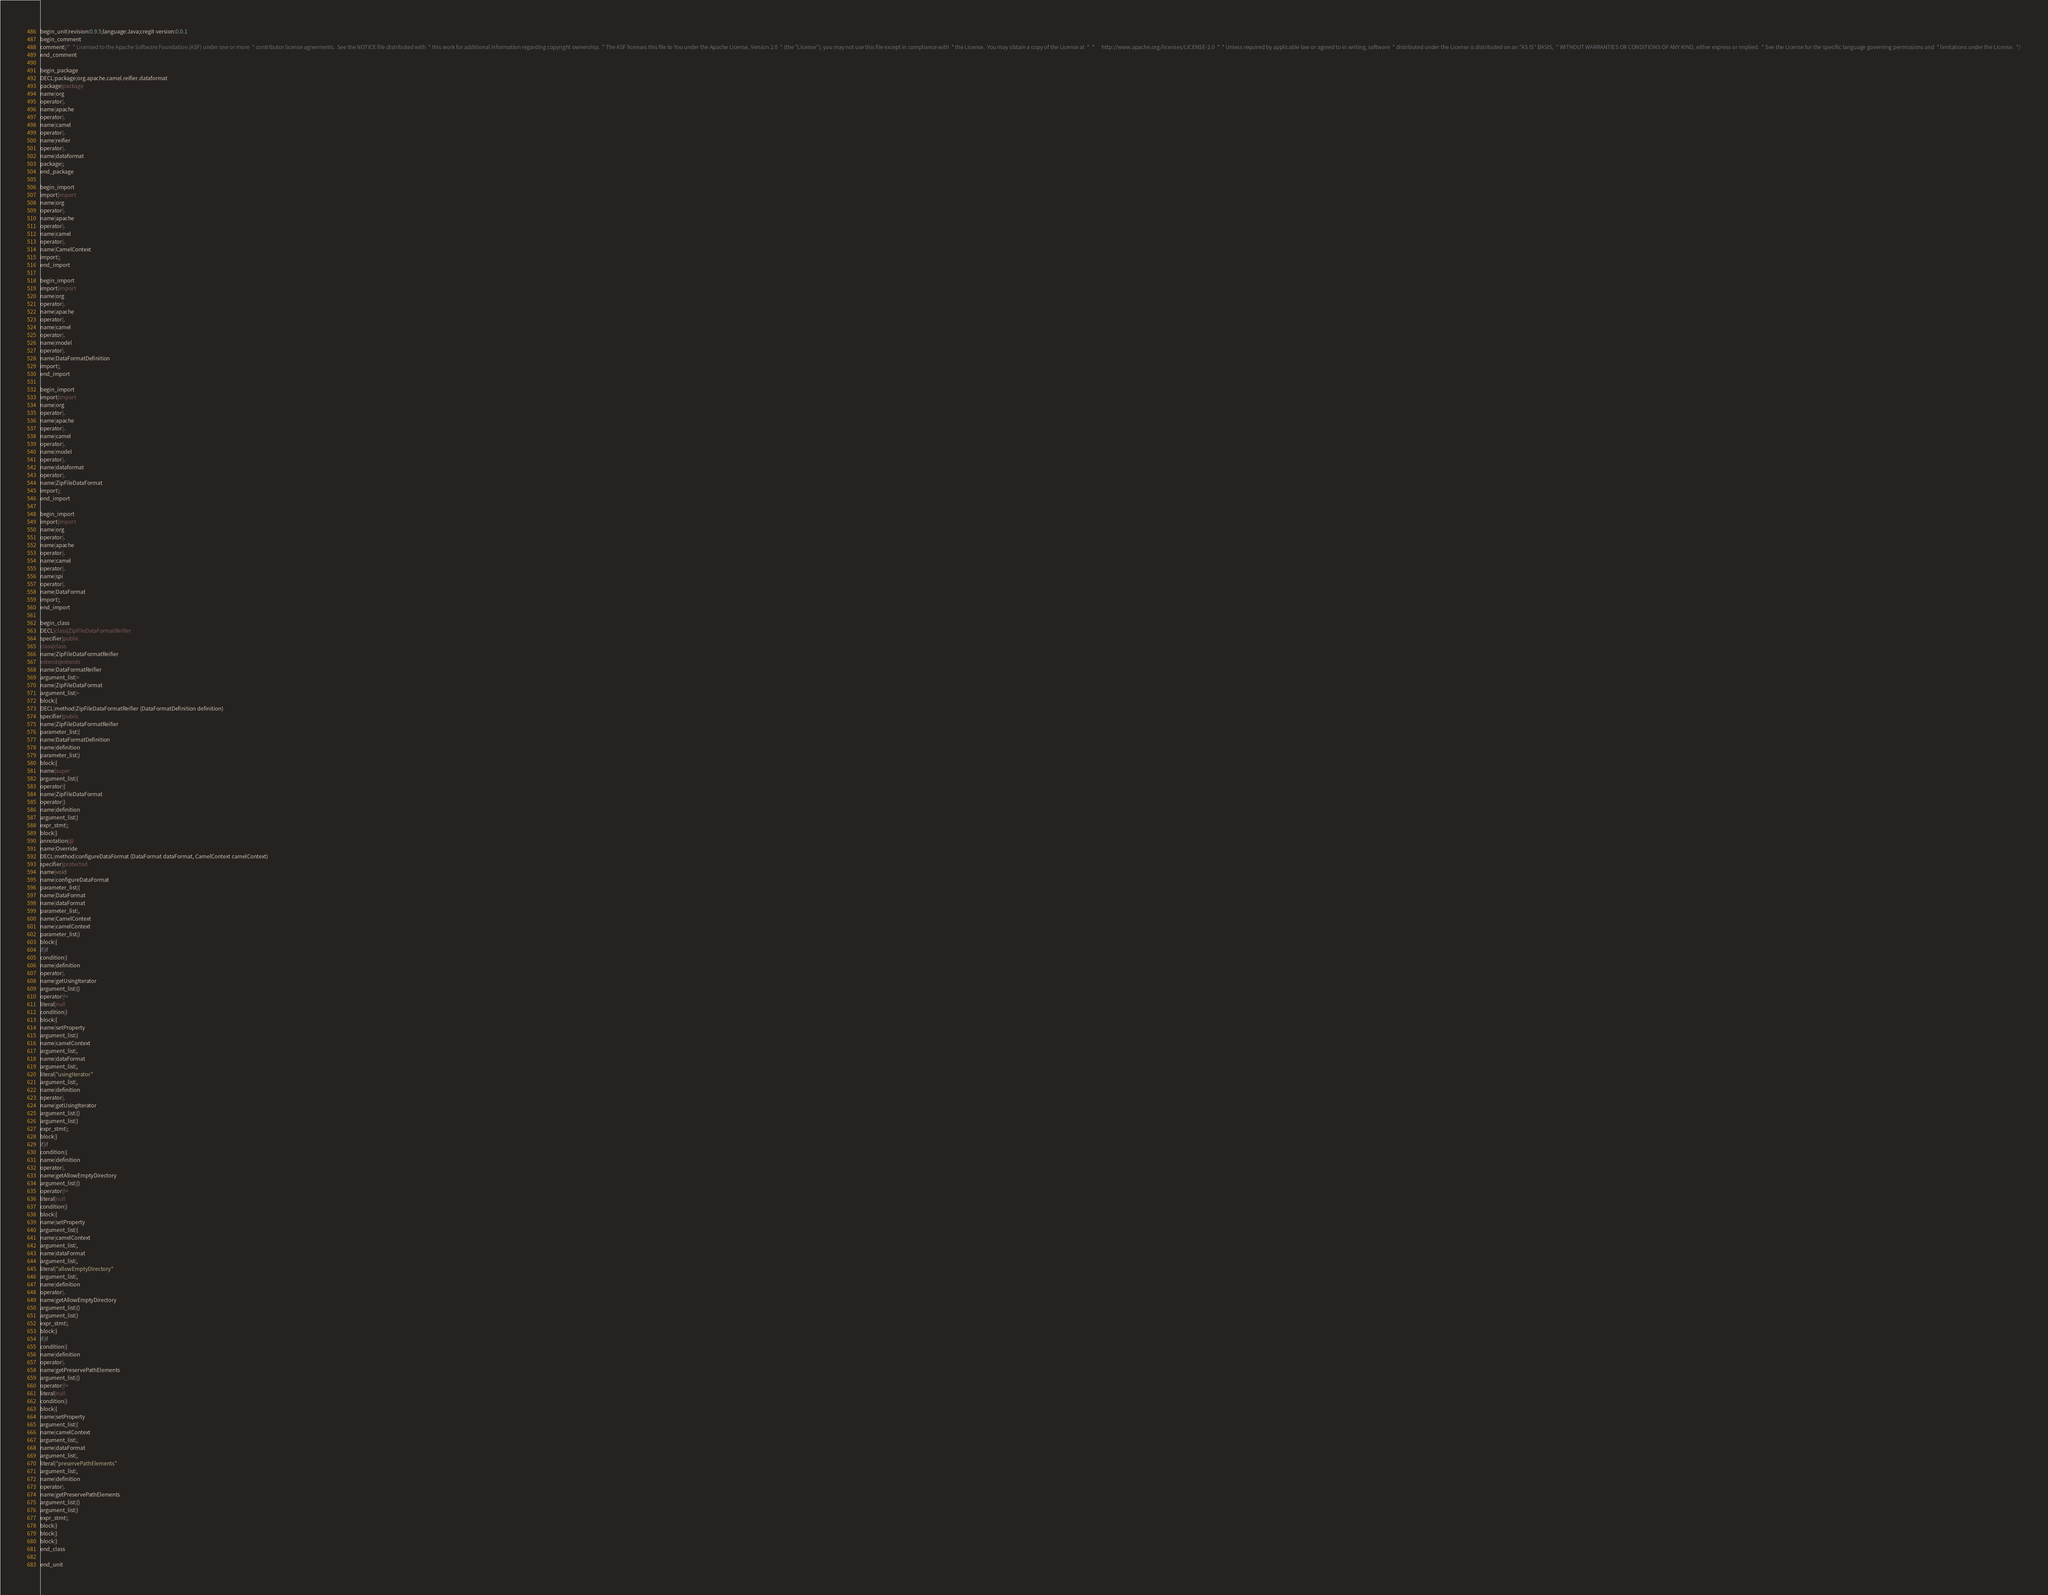Convert code to text. <code><loc_0><loc_0><loc_500><loc_500><_Java_>begin_unit|revision:0.9.5;language:Java;cregit-version:0.0.1
begin_comment
comment|/*  * Licensed to the Apache Software Foundation (ASF) under one or more  * contributor license agreements.  See the NOTICE file distributed with  * this work for additional information regarding copyright ownership.  * The ASF licenses this file to You under the Apache License, Version 2.0  * (the "License"); you may not use this file except in compliance with  * the License.  You may obtain a copy of the License at  *  *      http://www.apache.org/licenses/LICENSE-2.0  *  * Unless required by applicable law or agreed to in writing, software  * distributed under the License is distributed on an "AS IS" BASIS,  * WITHOUT WARRANTIES OR CONDITIONS OF ANY KIND, either express or implied.  * See the License for the specific language governing permissions and  * limitations under the License.  */
end_comment

begin_package
DECL|package|org.apache.camel.reifier.dataformat
package|package
name|org
operator|.
name|apache
operator|.
name|camel
operator|.
name|reifier
operator|.
name|dataformat
package|;
end_package

begin_import
import|import
name|org
operator|.
name|apache
operator|.
name|camel
operator|.
name|CamelContext
import|;
end_import

begin_import
import|import
name|org
operator|.
name|apache
operator|.
name|camel
operator|.
name|model
operator|.
name|DataFormatDefinition
import|;
end_import

begin_import
import|import
name|org
operator|.
name|apache
operator|.
name|camel
operator|.
name|model
operator|.
name|dataformat
operator|.
name|ZipFileDataFormat
import|;
end_import

begin_import
import|import
name|org
operator|.
name|apache
operator|.
name|camel
operator|.
name|spi
operator|.
name|DataFormat
import|;
end_import

begin_class
DECL|class|ZipFileDataFormatReifier
specifier|public
class|class
name|ZipFileDataFormatReifier
extends|extends
name|DataFormatReifier
argument_list|<
name|ZipFileDataFormat
argument_list|>
block|{
DECL|method|ZipFileDataFormatReifier (DataFormatDefinition definition)
specifier|public
name|ZipFileDataFormatReifier
parameter_list|(
name|DataFormatDefinition
name|definition
parameter_list|)
block|{
name|super
argument_list|(
operator|(
name|ZipFileDataFormat
operator|)
name|definition
argument_list|)
expr_stmt|;
block|}
annotation|@
name|Override
DECL|method|configureDataFormat (DataFormat dataFormat, CamelContext camelContext)
specifier|protected
name|void
name|configureDataFormat
parameter_list|(
name|DataFormat
name|dataFormat
parameter_list|,
name|CamelContext
name|camelContext
parameter_list|)
block|{
if|if
condition|(
name|definition
operator|.
name|getUsingIterator
argument_list|()
operator|!=
literal|null
condition|)
block|{
name|setProperty
argument_list|(
name|camelContext
argument_list|,
name|dataFormat
argument_list|,
literal|"usingIterator"
argument_list|,
name|definition
operator|.
name|getUsingIterator
argument_list|()
argument_list|)
expr_stmt|;
block|}
if|if
condition|(
name|definition
operator|.
name|getAllowEmptyDirectory
argument_list|()
operator|!=
literal|null
condition|)
block|{
name|setProperty
argument_list|(
name|camelContext
argument_list|,
name|dataFormat
argument_list|,
literal|"allowEmptyDirectory"
argument_list|,
name|definition
operator|.
name|getAllowEmptyDirectory
argument_list|()
argument_list|)
expr_stmt|;
block|}
if|if
condition|(
name|definition
operator|.
name|getPreservePathElements
argument_list|()
operator|!=
literal|null
condition|)
block|{
name|setProperty
argument_list|(
name|camelContext
argument_list|,
name|dataFormat
argument_list|,
literal|"preservePathElements"
argument_list|,
name|definition
operator|.
name|getPreservePathElements
argument_list|()
argument_list|)
expr_stmt|;
block|}
block|}
block|}
end_class

end_unit

</code> 